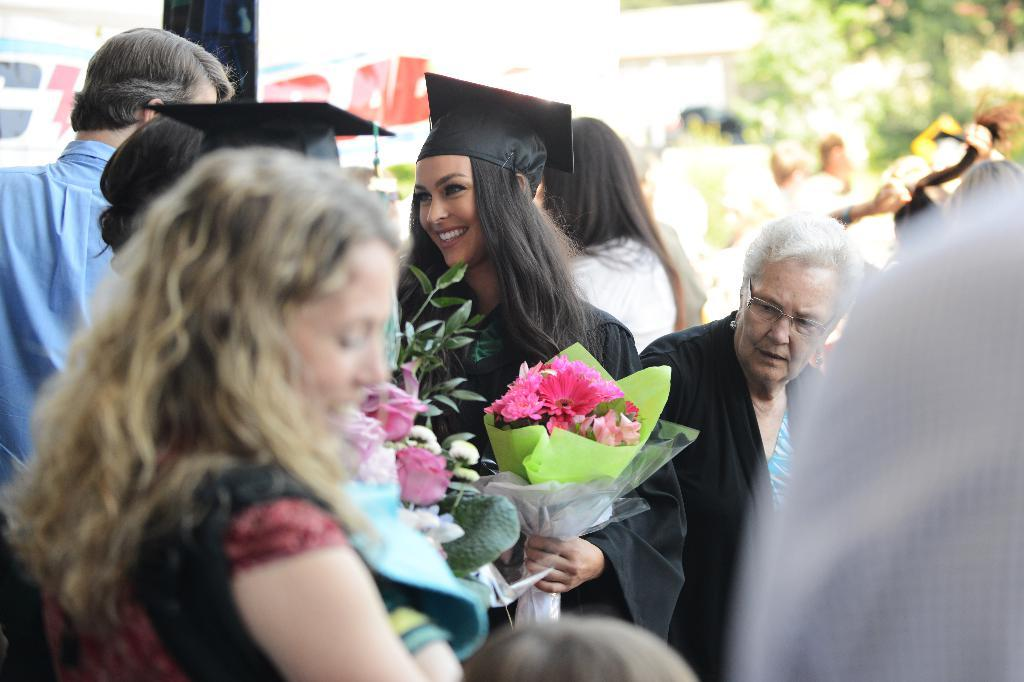How many people are in the image? There are people in the image, but the exact number is not specified. What is the person wearing in the image? The person is wearing a black coat and black hat. What is the person holding in the image? The person is holding a bouquet. What type of objects can be seen in the image besides people? There are colorful flowers in the image. Where is the camp located in the image? There is no camp present in the image. What is the brain doing in the image? There is no brain present in the image. 